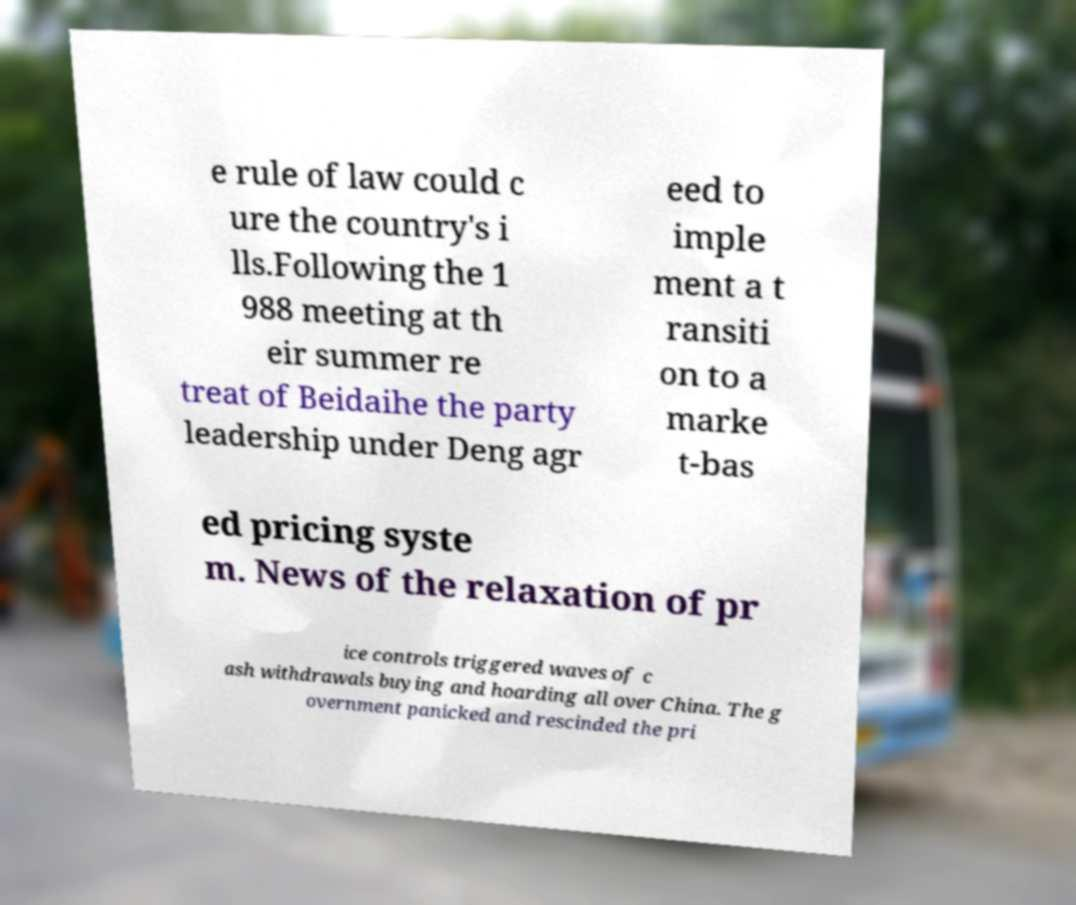Could you assist in decoding the text presented in this image and type it out clearly? e rule of law could c ure the country's i lls.Following the 1 988 meeting at th eir summer re treat of Beidaihe the party leadership under Deng agr eed to imple ment a t ransiti on to a marke t-bas ed pricing syste m. News of the relaxation of pr ice controls triggered waves of c ash withdrawals buying and hoarding all over China. The g overnment panicked and rescinded the pri 